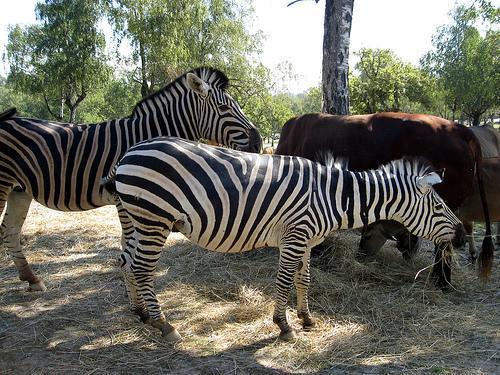How many animals in this photograph?
Give a very brief answer. 3. How many zebras in this photograph?
Give a very brief answer. 2. How many zebras are shown?
Give a very brief answer. 2. 